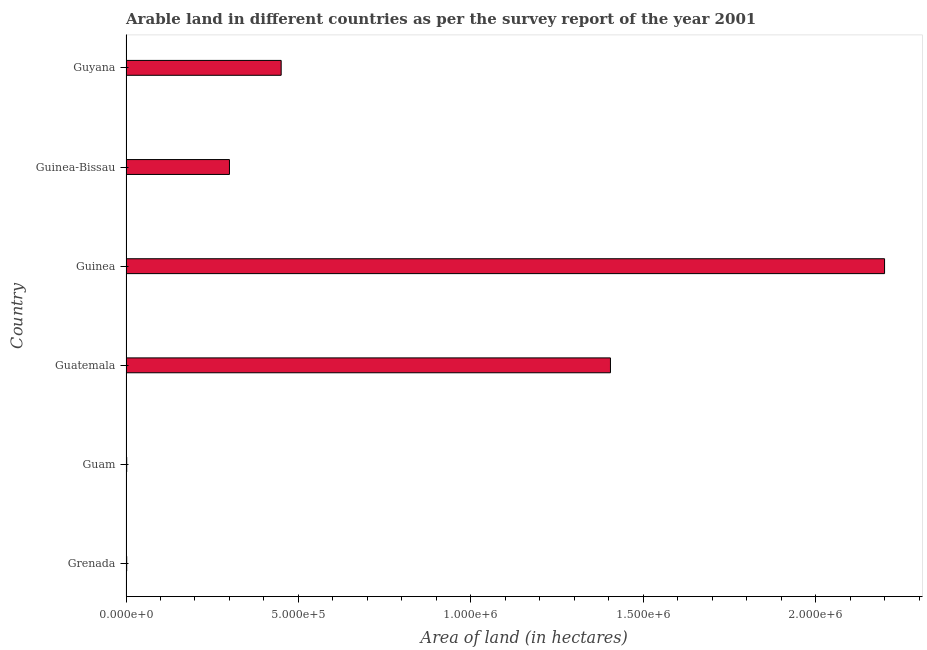Does the graph contain grids?
Provide a succinct answer. No. What is the title of the graph?
Provide a succinct answer. Arable land in different countries as per the survey report of the year 2001. What is the label or title of the X-axis?
Make the answer very short. Area of land (in hectares). Across all countries, what is the maximum area of land?
Provide a succinct answer. 2.20e+06. Across all countries, what is the minimum area of land?
Provide a short and direct response. 2000. In which country was the area of land maximum?
Offer a very short reply. Guinea. In which country was the area of land minimum?
Keep it short and to the point. Grenada. What is the sum of the area of land?
Ensure brevity in your answer.  4.36e+06. What is the difference between the area of land in Grenada and Guinea?
Your answer should be very brief. -2.20e+06. What is the average area of land per country?
Make the answer very short. 7.26e+05. What is the median area of land?
Keep it short and to the point. 3.75e+05. In how many countries, is the area of land greater than 1300000 hectares?
Ensure brevity in your answer.  2. What is the ratio of the area of land in Guatemala to that in Guinea-Bissau?
Provide a short and direct response. 4.68. What is the difference between the highest and the second highest area of land?
Keep it short and to the point. 7.95e+05. Is the sum of the area of land in Guatemala and Guinea greater than the maximum area of land across all countries?
Your answer should be compact. Yes. What is the difference between the highest and the lowest area of land?
Your response must be concise. 2.20e+06. In how many countries, is the area of land greater than the average area of land taken over all countries?
Ensure brevity in your answer.  2. How many bars are there?
Offer a terse response. 6. Are all the bars in the graph horizontal?
Ensure brevity in your answer.  Yes. What is the difference between two consecutive major ticks on the X-axis?
Offer a terse response. 5.00e+05. What is the Area of land (in hectares) of Guatemala?
Ensure brevity in your answer.  1.40e+06. What is the Area of land (in hectares) of Guinea?
Provide a succinct answer. 2.20e+06. What is the Area of land (in hectares) of Guyana?
Keep it short and to the point. 4.50e+05. What is the difference between the Area of land (in hectares) in Grenada and Guam?
Your answer should be very brief. 0. What is the difference between the Area of land (in hectares) in Grenada and Guatemala?
Offer a very short reply. -1.40e+06. What is the difference between the Area of land (in hectares) in Grenada and Guinea?
Offer a very short reply. -2.20e+06. What is the difference between the Area of land (in hectares) in Grenada and Guinea-Bissau?
Offer a very short reply. -2.98e+05. What is the difference between the Area of land (in hectares) in Grenada and Guyana?
Your answer should be very brief. -4.48e+05. What is the difference between the Area of land (in hectares) in Guam and Guatemala?
Your answer should be very brief. -1.40e+06. What is the difference between the Area of land (in hectares) in Guam and Guinea?
Your response must be concise. -2.20e+06. What is the difference between the Area of land (in hectares) in Guam and Guinea-Bissau?
Offer a very short reply. -2.98e+05. What is the difference between the Area of land (in hectares) in Guam and Guyana?
Make the answer very short. -4.48e+05. What is the difference between the Area of land (in hectares) in Guatemala and Guinea?
Your answer should be compact. -7.95e+05. What is the difference between the Area of land (in hectares) in Guatemala and Guinea-Bissau?
Provide a short and direct response. 1.10e+06. What is the difference between the Area of land (in hectares) in Guatemala and Guyana?
Provide a succinct answer. 9.55e+05. What is the difference between the Area of land (in hectares) in Guinea and Guinea-Bissau?
Ensure brevity in your answer.  1.90e+06. What is the difference between the Area of land (in hectares) in Guinea and Guyana?
Make the answer very short. 1.75e+06. What is the difference between the Area of land (in hectares) in Guinea-Bissau and Guyana?
Your answer should be very brief. -1.50e+05. What is the ratio of the Area of land (in hectares) in Grenada to that in Guinea-Bissau?
Give a very brief answer. 0.01. What is the ratio of the Area of land (in hectares) in Grenada to that in Guyana?
Give a very brief answer. 0. What is the ratio of the Area of land (in hectares) in Guam to that in Guinea?
Give a very brief answer. 0. What is the ratio of the Area of land (in hectares) in Guam to that in Guinea-Bissau?
Your answer should be compact. 0.01. What is the ratio of the Area of land (in hectares) in Guam to that in Guyana?
Provide a succinct answer. 0. What is the ratio of the Area of land (in hectares) in Guatemala to that in Guinea?
Keep it short and to the point. 0.64. What is the ratio of the Area of land (in hectares) in Guatemala to that in Guinea-Bissau?
Make the answer very short. 4.68. What is the ratio of the Area of land (in hectares) in Guatemala to that in Guyana?
Provide a succinct answer. 3.12. What is the ratio of the Area of land (in hectares) in Guinea to that in Guinea-Bissau?
Make the answer very short. 7.33. What is the ratio of the Area of land (in hectares) in Guinea to that in Guyana?
Keep it short and to the point. 4.89. What is the ratio of the Area of land (in hectares) in Guinea-Bissau to that in Guyana?
Keep it short and to the point. 0.67. 